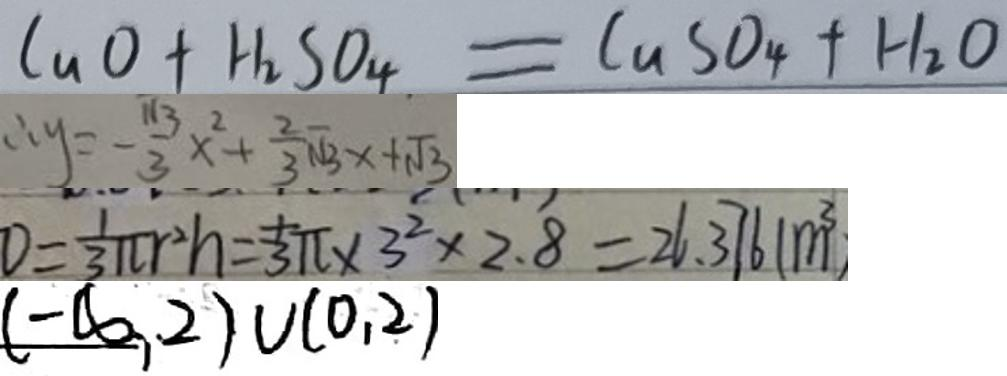<formula> <loc_0><loc_0><loc_500><loc_500>C u O _ { 4 } + H _ { 2 } S O _ { 4 } = C u S O _ { 4 } + H _ { 2 } O 
 \therefore y = - \frac { \sqrt { 3 } } { 3 } x ^ { 2 } + \frac { 2 } { 3 } \sqrt { 3 } x + \sqrt { 3 } 
 D = \frac { 1 } { 3 } \pi r ^ { 2 } h = \frac { 1 } { 3 } \pi \times 3 ^ { 2 } \times 2 . 8 = 2 6 . 3 7 6 1 ( m ^ { 3 } 
 ( - \infty , 0 ) \cup ( 0 , 2 )</formula> 